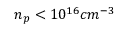<formula> <loc_0><loc_0><loc_500><loc_500>n _ { p } < 1 0 ^ { 1 6 } c m ^ { - 3 }</formula> 